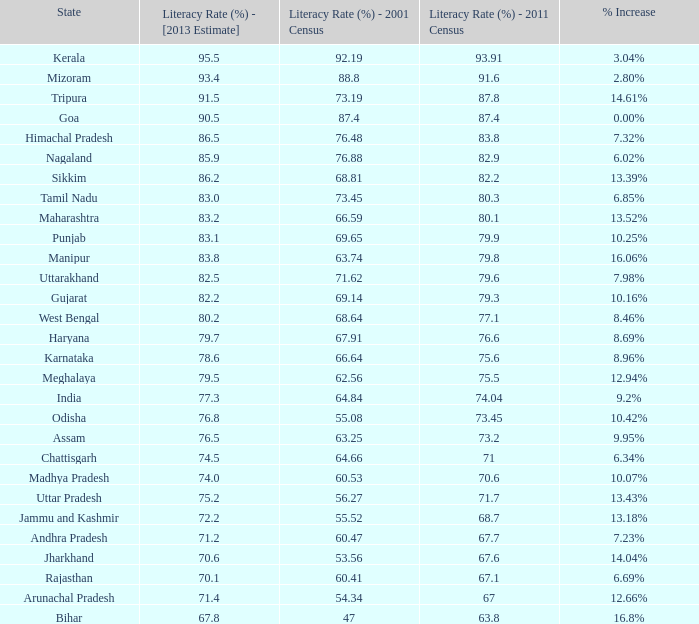Would you mind parsing the complete table? {'header': ['State', 'Literacy Rate (%) - [2013 Estimate]', 'Literacy Rate (%) - 2001 Census', 'Literacy Rate (%) - 2011 Census', '% Increase'], 'rows': [['Kerala', '95.5', '92.19', '93.91', '3.04%'], ['Mizoram', '93.4', '88.8', '91.6', '2.80%'], ['Tripura', '91.5', '73.19', '87.8', '14.61%'], ['Goa', '90.5', '87.4', '87.4', '0.00%'], ['Himachal Pradesh', '86.5', '76.48', '83.8', '7.32%'], ['Nagaland', '85.9', '76.88', '82.9', '6.02%'], ['Sikkim', '86.2', '68.81', '82.2', '13.39%'], ['Tamil Nadu', '83.0', '73.45', '80.3', '6.85%'], ['Maharashtra', '83.2', '66.59', '80.1', '13.52%'], ['Punjab', '83.1', '69.65', '79.9', '10.25%'], ['Manipur', '83.8', '63.74', '79.8', '16.06%'], ['Uttarakhand', '82.5', '71.62', '79.6', '7.98%'], ['Gujarat', '82.2', '69.14', '79.3', '10.16%'], ['West Bengal', '80.2', '68.64', '77.1', '8.46%'], ['Haryana', '79.7', '67.91', '76.6', '8.69%'], ['Karnataka', '78.6', '66.64', '75.6', '8.96%'], ['Meghalaya', '79.5', '62.56', '75.5', '12.94%'], ['India', '77.3', '64.84', '74.04', '9.2%'], ['Odisha', '76.8', '55.08', '73.45', '10.42%'], ['Assam', '76.5', '63.25', '73.2', '9.95%'], ['Chattisgarh', '74.5', '64.66', '71', '6.34%'], ['Madhya Pradesh', '74.0', '60.53', '70.6', '10.07%'], ['Uttar Pradesh', '75.2', '56.27', '71.7', '13.43%'], ['Jammu and Kashmir', '72.2', '55.52', '68.7', '13.18%'], ['Andhra Pradesh', '71.2', '60.47', '67.7', '7.23%'], ['Jharkhand', '70.6', '53.56', '67.6', '14.04%'], ['Rajasthan', '70.1', '60.41', '67.1', '6.69%'], ['Arunachal Pradesh', '71.4', '54.34', '67', '12.66%'], ['Bihar', '67.8', '47', '63.8', '16.8%']]} What was the literacy rate registered in the 2001 census for the state that observed a 1 54.34. 